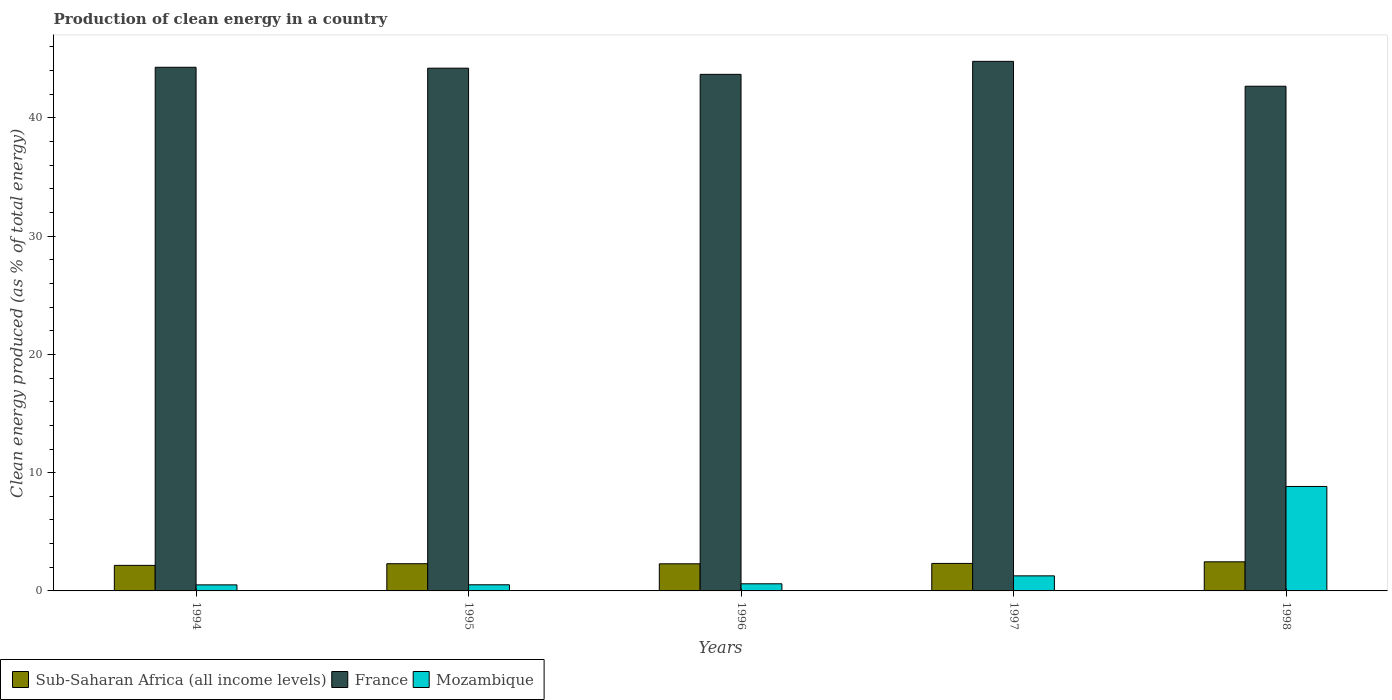Are the number of bars per tick equal to the number of legend labels?
Offer a very short reply. Yes. How many bars are there on the 2nd tick from the right?
Provide a succinct answer. 3. What is the percentage of clean energy produced in Sub-Saharan Africa (all income levels) in 1998?
Offer a very short reply. 2.46. Across all years, what is the maximum percentage of clean energy produced in Mozambique?
Offer a very short reply. 8.83. Across all years, what is the minimum percentage of clean energy produced in Mozambique?
Provide a succinct answer. 0.51. What is the total percentage of clean energy produced in Mozambique in the graph?
Your answer should be compact. 11.74. What is the difference between the percentage of clean energy produced in Sub-Saharan Africa (all income levels) in 1994 and that in 1995?
Provide a succinct answer. -0.14. What is the difference between the percentage of clean energy produced in Mozambique in 1994 and the percentage of clean energy produced in Sub-Saharan Africa (all income levels) in 1995?
Your answer should be compact. -1.79. What is the average percentage of clean energy produced in France per year?
Provide a succinct answer. 43.93. In the year 1998, what is the difference between the percentage of clean energy produced in Mozambique and percentage of clean energy produced in France?
Offer a very short reply. -33.85. In how many years, is the percentage of clean energy produced in Sub-Saharan Africa (all income levels) greater than 16 %?
Offer a terse response. 0. What is the ratio of the percentage of clean energy produced in Mozambique in 1994 to that in 1996?
Your response must be concise. 0.85. Is the percentage of clean energy produced in Sub-Saharan Africa (all income levels) in 1994 less than that in 1998?
Offer a very short reply. Yes. Is the difference between the percentage of clean energy produced in Mozambique in 1995 and 1997 greater than the difference between the percentage of clean energy produced in France in 1995 and 1997?
Give a very brief answer. No. What is the difference between the highest and the second highest percentage of clean energy produced in France?
Your answer should be very brief. 0.5. What is the difference between the highest and the lowest percentage of clean energy produced in France?
Keep it short and to the point. 2.1. What does the 2nd bar from the left in 1996 represents?
Keep it short and to the point. France. What does the 1st bar from the right in 1995 represents?
Provide a short and direct response. Mozambique. Is it the case that in every year, the sum of the percentage of clean energy produced in Sub-Saharan Africa (all income levels) and percentage of clean energy produced in Mozambique is greater than the percentage of clean energy produced in France?
Provide a short and direct response. No. How many bars are there?
Provide a succinct answer. 15. Are the values on the major ticks of Y-axis written in scientific E-notation?
Provide a short and direct response. No. Does the graph contain grids?
Keep it short and to the point. No. Where does the legend appear in the graph?
Keep it short and to the point. Bottom left. What is the title of the graph?
Give a very brief answer. Production of clean energy in a country. What is the label or title of the X-axis?
Make the answer very short. Years. What is the label or title of the Y-axis?
Provide a succinct answer. Clean energy produced (as % of total energy). What is the Clean energy produced (as % of total energy) in Sub-Saharan Africa (all income levels) in 1994?
Provide a short and direct response. 2.16. What is the Clean energy produced (as % of total energy) of France in 1994?
Ensure brevity in your answer.  44.28. What is the Clean energy produced (as % of total energy) of Mozambique in 1994?
Give a very brief answer. 0.51. What is the Clean energy produced (as % of total energy) of Sub-Saharan Africa (all income levels) in 1995?
Give a very brief answer. 2.3. What is the Clean energy produced (as % of total energy) of France in 1995?
Offer a very short reply. 44.21. What is the Clean energy produced (as % of total energy) in Mozambique in 1995?
Provide a short and direct response. 0.52. What is the Clean energy produced (as % of total energy) in Sub-Saharan Africa (all income levels) in 1996?
Your answer should be compact. 2.29. What is the Clean energy produced (as % of total energy) in France in 1996?
Your response must be concise. 43.68. What is the Clean energy produced (as % of total energy) in Mozambique in 1996?
Your response must be concise. 0.6. What is the Clean energy produced (as % of total energy) of Sub-Saharan Africa (all income levels) in 1997?
Give a very brief answer. 2.32. What is the Clean energy produced (as % of total energy) in France in 1997?
Your response must be concise. 44.78. What is the Clean energy produced (as % of total energy) in Mozambique in 1997?
Offer a terse response. 1.27. What is the Clean energy produced (as % of total energy) of Sub-Saharan Africa (all income levels) in 1998?
Your answer should be compact. 2.46. What is the Clean energy produced (as % of total energy) of France in 1998?
Offer a very short reply. 42.68. What is the Clean energy produced (as % of total energy) of Mozambique in 1998?
Provide a succinct answer. 8.83. Across all years, what is the maximum Clean energy produced (as % of total energy) of Sub-Saharan Africa (all income levels)?
Ensure brevity in your answer.  2.46. Across all years, what is the maximum Clean energy produced (as % of total energy) in France?
Make the answer very short. 44.78. Across all years, what is the maximum Clean energy produced (as % of total energy) of Mozambique?
Make the answer very short. 8.83. Across all years, what is the minimum Clean energy produced (as % of total energy) in Sub-Saharan Africa (all income levels)?
Ensure brevity in your answer.  2.16. Across all years, what is the minimum Clean energy produced (as % of total energy) in France?
Ensure brevity in your answer.  42.68. Across all years, what is the minimum Clean energy produced (as % of total energy) in Mozambique?
Provide a succinct answer. 0.51. What is the total Clean energy produced (as % of total energy) in Sub-Saharan Africa (all income levels) in the graph?
Offer a very short reply. 11.54. What is the total Clean energy produced (as % of total energy) of France in the graph?
Your response must be concise. 219.63. What is the total Clean energy produced (as % of total energy) of Mozambique in the graph?
Keep it short and to the point. 11.74. What is the difference between the Clean energy produced (as % of total energy) of Sub-Saharan Africa (all income levels) in 1994 and that in 1995?
Offer a terse response. -0.14. What is the difference between the Clean energy produced (as % of total energy) of France in 1994 and that in 1995?
Give a very brief answer. 0.08. What is the difference between the Clean energy produced (as % of total energy) of Mozambique in 1994 and that in 1995?
Provide a short and direct response. -0.01. What is the difference between the Clean energy produced (as % of total energy) in Sub-Saharan Africa (all income levels) in 1994 and that in 1996?
Provide a succinct answer. -0.13. What is the difference between the Clean energy produced (as % of total energy) in France in 1994 and that in 1996?
Ensure brevity in your answer.  0.6. What is the difference between the Clean energy produced (as % of total energy) in Mozambique in 1994 and that in 1996?
Offer a terse response. -0.09. What is the difference between the Clean energy produced (as % of total energy) of Sub-Saharan Africa (all income levels) in 1994 and that in 1997?
Ensure brevity in your answer.  -0.16. What is the difference between the Clean energy produced (as % of total energy) of France in 1994 and that in 1997?
Ensure brevity in your answer.  -0.5. What is the difference between the Clean energy produced (as % of total energy) in Mozambique in 1994 and that in 1997?
Give a very brief answer. -0.76. What is the difference between the Clean energy produced (as % of total energy) of Sub-Saharan Africa (all income levels) in 1994 and that in 1998?
Ensure brevity in your answer.  -0.3. What is the difference between the Clean energy produced (as % of total energy) in France in 1994 and that in 1998?
Your answer should be compact. 1.6. What is the difference between the Clean energy produced (as % of total energy) in Mozambique in 1994 and that in 1998?
Your response must be concise. -8.32. What is the difference between the Clean energy produced (as % of total energy) in Sub-Saharan Africa (all income levels) in 1995 and that in 1996?
Offer a terse response. 0.01. What is the difference between the Clean energy produced (as % of total energy) of France in 1995 and that in 1996?
Make the answer very short. 0.52. What is the difference between the Clean energy produced (as % of total energy) in Mozambique in 1995 and that in 1996?
Make the answer very short. -0.08. What is the difference between the Clean energy produced (as % of total energy) in Sub-Saharan Africa (all income levels) in 1995 and that in 1997?
Give a very brief answer. -0.02. What is the difference between the Clean energy produced (as % of total energy) of France in 1995 and that in 1997?
Give a very brief answer. -0.58. What is the difference between the Clean energy produced (as % of total energy) of Mozambique in 1995 and that in 1997?
Offer a very short reply. -0.76. What is the difference between the Clean energy produced (as % of total energy) in Sub-Saharan Africa (all income levels) in 1995 and that in 1998?
Your answer should be compact. -0.16. What is the difference between the Clean energy produced (as % of total energy) in France in 1995 and that in 1998?
Give a very brief answer. 1.53. What is the difference between the Clean energy produced (as % of total energy) of Mozambique in 1995 and that in 1998?
Make the answer very short. -8.31. What is the difference between the Clean energy produced (as % of total energy) in Sub-Saharan Africa (all income levels) in 1996 and that in 1997?
Provide a short and direct response. -0.03. What is the difference between the Clean energy produced (as % of total energy) in France in 1996 and that in 1997?
Keep it short and to the point. -1.1. What is the difference between the Clean energy produced (as % of total energy) of Mozambique in 1996 and that in 1997?
Give a very brief answer. -0.67. What is the difference between the Clean energy produced (as % of total energy) of Sub-Saharan Africa (all income levels) in 1996 and that in 1998?
Your response must be concise. -0.17. What is the difference between the Clean energy produced (as % of total energy) of France in 1996 and that in 1998?
Provide a short and direct response. 1. What is the difference between the Clean energy produced (as % of total energy) in Mozambique in 1996 and that in 1998?
Provide a succinct answer. -8.23. What is the difference between the Clean energy produced (as % of total energy) of Sub-Saharan Africa (all income levels) in 1997 and that in 1998?
Offer a terse response. -0.14. What is the difference between the Clean energy produced (as % of total energy) in France in 1997 and that in 1998?
Your answer should be very brief. 2.1. What is the difference between the Clean energy produced (as % of total energy) in Mozambique in 1997 and that in 1998?
Provide a succinct answer. -7.56. What is the difference between the Clean energy produced (as % of total energy) of Sub-Saharan Africa (all income levels) in 1994 and the Clean energy produced (as % of total energy) of France in 1995?
Offer a terse response. -42.05. What is the difference between the Clean energy produced (as % of total energy) of Sub-Saharan Africa (all income levels) in 1994 and the Clean energy produced (as % of total energy) of Mozambique in 1995?
Your answer should be compact. 1.64. What is the difference between the Clean energy produced (as % of total energy) of France in 1994 and the Clean energy produced (as % of total energy) of Mozambique in 1995?
Offer a terse response. 43.76. What is the difference between the Clean energy produced (as % of total energy) in Sub-Saharan Africa (all income levels) in 1994 and the Clean energy produced (as % of total energy) in France in 1996?
Your answer should be very brief. -41.52. What is the difference between the Clean energy produced (as % of total energy) in Sub-Saharan Africa (all income levels) in 1994 and the Clean energy produced (as % of total energy) in Mozambique in 1996?
Your response must be concise. 1.56. What is the difference between the Clean energy produced (as % of total energy) in France in 1994 and the Clean energy produced (as % of total energy) in Mozambique in 1996?
Your answer should be compact. 43.68. What is the difference between the Clean energy produced (as % of total energy) in Sub-Saharan Africa (all income levels) in 1994 and the Clean energy produced (as % of total energy) in France in 1997?
Make the answer very short. -42.62. What is the difference between the Clean energy produced (as % of total energy) in Sub-Saharan Africa (all income levels) in 1994 and the Clean energy produced (as % of total energy) in Mozambique in 1997?
Your answer should be very brief. 0.89. What is the difference between the Clean energy produced (as % of total energy) in France in 1994 and the Clean energy produced (as % of total energy) in Mozambique in 1997?
Keep it short and to the point. 43.01. What is the difference between the Clean energy produced (as % of total energy) of Sub-Saharan Africa (all income levels) in 1994 and the Clean energy produced (as % of total energy) of France in 1998?
Offer a very short reply. -40.52. What is the difference between the Clean energy produced (as % of total energy) in Sub-Saharan Africa (all income levels) in 1994 and the Clean energy produced (as % of total energy) in Mozambique in 1998?
Provide a short and direct response. -6.67. What is the difference between the Clean energy produced (as % of total energy) in France in 1994 and the Clean energy produced (as % of total energy) in Mozambique in 1998?
Give a very brief answer. 35.45. What is the difference between the Clean energy produced (as % of total energy) in Sub-Saharan Africa (all income levels) in 1995 and the Clean energy produced (as % of total energy) in France in 1996?
Give a very brief answer. -41.38. What is the difference between the Clean energy produced (as % of total energy) in Sub-Saharan Africa (all income levels) in 1995 and the Clean energy produced (as % of total energy) in Mozambique in 1996?
Your answer should be compact. 1.7. What is the difference between the Clean energy produced (as % of total energy) of France in 1995 and the Clean energy produced (as % of total energy) of Mozambique in 1996?
Offer a terse response. 43.6. What is the difference between the Clean energy produced (as % of total energy) of Sub-Saharan Africa (all income levels) in 1995 and the Clean energy produced (as % of total energy) of France in 1997?
Provide a short and direct response. -42.48. What is the difference between the Clean energy produced (as % of total energy) in Sub-Saharan Africa (all income levels) in 1995 and the Clean energy produced (as % of total energy) in Mozambique in 1997?
Your answer should be very brief. 1.03. What is the difference between the Clean energy produced (as % of total energy) of France in 1995 and the Clean energy produced (as % of total energy) of Mozambique in 1997?
Your answer should be very brief. 42.93. What is the difference between the Clean energy produced (as % of total energy) in Sub-Saharan Africa (all income levels) in 1995 and the Clean energy produced (as % of total energy) in France in 1998?
Ensure brevity in your answer.  -40.38. What is the difference between the Clean energy produced (as % of total energy) in Sub-Saharan Africa (all income levels) in 1995 and the Clean energy produced (as % of total energy) in Mozambique in 1998?
Your answer should be compact. -6.53. What is the difference between the Clean energy produced (as % of total energy) of France in 1995 and the Clean energy produced (as % of total energy) of Mozambique in 1998?
Offer a very short reply. 35.37. What is the difference between the Clean energy produced (as % of total energy) in Sub-Saharan Africa (all income levels) in 1996 and the Clean energy produced (as % of total energy) in France in 1997?
Your answer should be very brief. -42.49. What is the difference between the Clean energy produced (as % of total energy) of Sub-Saharan Africa (all income levels) in 1996 and the Clean energy produced (as % of total energy) of Mozambique in 1997?
Provide a succinct answer. 1.02. What is the difference between the Clean energy produced (as % of total energy) of France in 1996 and the Clean energy produced (as % of total energy) of Mozambique in 1997?
Give a very brief answer. 42.41. What is the difference between the Clean energy produced (as % of total energy) of Sub-Saharan Africa (all income levels) in 1996 and the Clean energy produced (as % of total energy) of France in 1998?
Your answer should be very brief. -40.39. What is the difference between the Clean energy produced (as % of total energy) in Sub-Saharan Africa (all income levels) in 1996 and the Clean energy produced (as % of total energy) in Mozambique in 1998?
Make the answer very short. -6.54. What is the difference between the Clean energy produced (as % of total energy) of France in 1996 and the Clean energy produced (as % of total energy) of Mozambique in 1998?
Offer a terse response. 34.85. What is the difference between the Clean energy produced (as % of total energy) of Sub-Saharan Africa (all income levels) in 1997 and the Clean energy produced (as % of total energy) of France in 1998?
Your response must be concise. -40.35. What is the difference between the Clean energy produced (as % of total energy) of Sub-Saharan Africa (all income levels) in 1997 and the Clean energy produced (as % of total energy) of Mozambique in 1998?
Provide a succinct answer. -6.51. What is the difference between the Clean energy produced (as % of total energy) of France in 1997 and the Clean energy produced (as % of total energy) of Mozambique in 1998?
Offer a terse response. 35.95. What is the average Clean energy produced (as % of total energy) of Sub-Saharan Africa (all income levels) per year?
Keep it short and to the point. 2.31. What is the average Clean energy produced (as % of total energy) in France per year?
Give a very brief answer. 43.93. What is the average Clean energy produced (as % of total energy) in Mozambique per year?
Make the answer very short. 2.35. In the year 1994, what is the difference between the Clean energy produced (as % of total energy) in Sub-Saharan Africa (all income levels) and Clean energy produced (as % of total energy) in France?
Keep it short and to the point. -42.12. In the year 1994, what is the difference between the Clean energy produced (as % of total energy) of Sub-Saharan Africa (all income levels) and Clean energy produced (as % of total energy) of Mozambique?
Your answer should be compact. 1.65. In the year 1994, what is the difference between the Clean energy produced (as % of total energy) of France and Clean energy produced (as % of total energy) of Mozambique?
Offer a terse response. 43.77. In the year 1995, what is the difference between the Clean energy produced (as % of total energy) in Sub-Saharan Africa (all income levels) and Clean energy produced (as % of total energy) in France?
Keep it short and to the point. -41.91. In the year 1995, what is the difference between the Clean energy produced (as % of total energy) of Sub-Saharan Africa (all income levels) and Clean energy produced (as % of total energy) of Mozambique?
Offer a very short reply. 1.78. In the year 1995, what is the difference between the Clean energy produced (as % of total energy) in France and Clean energy produced (as % of total energy) in Mozambique?
Provide a succinct answer. 43.69. In the year 1996, what is the difference between the Clean energy produced (as % of total energy) of Sub-Saharan Africa (all income levels) and Clean energy produced (as % of total energy) of France?
Your answer should be compact. -41.39. In the year 1996, what is the difference between the Clean energy produced (as % of total energy) of Sub-Saharan Africa (all income levels) and Clean energy produced (as % of total energy) of Mozambique?
Offer a very short reply. 1.69. In the year 1996, what is the difference between the Clean energy produced (as % of total energy) in France and Clean energy produced (as % of total energy) in Mozambique?
Provide a succinct answer. 43.08. In the year 1997, what is the difference between the Clean energy produced (as % of total energy) in Sub-Saharan Africa (all income levels) and Clean energy produced (as % of total energy) in France?
Your response must be concise. -42.46. In the year 1997, what is the difference between the Clean energy produced (as % of total energy) in Sub-Saharan Africa (all income levels) and Clean energy produced (as % of total energy) in Mozambique?
Ensure brevity in your answer.  1.05. In the year 1997, what is the difference between the Clean energy produced (as % of total energy) of France and Clean energy produced (as % of total energy) of Mozambique?
Provide a short and direct response. 43.51. In the year 1998, what is the difference between the Clean energy produced (as % of total energy) in Sub-Saharan Africa (all income levels) and Clean energy produced (as % of total energy) in France?
Offer a terse response. -40.22. In the year 1998, what is the difference between the Clean energy produced (as % of total energy) in Sub-Saharan Africa (all income levels) and Clean energy produced (as % of total energy) in Mozambique?
Your response must be concise. -6.37. In the year 1998, what is the difference between the Clean energy produced (as % of total energy) in France and Clean energy produced (as % of total energy) in Mozambique?
Ensure brevity in your answer.  33.85. What is the ratio of the Clean energy produced (as % of total energy) of Sub-Saharan Africa (all income levels) in 1994 to that in 1995?
Make the answer very short. 0.94. What is the ratio of the Clean energy produced (as % of total energy) in Mozambique in 1994 to that in 1995?
Make the answer very short. 0.99. What is the ratio of the Clean energy produced (as % of total energy) of Sub-Saharan Africa (all income levels) in 1994 to that in 1996?
Provide a short and direct response. 0.94. What is the ratio of the Clean energy produced (as % of total energy) in France in 1994 to that in 1996?
Your answer should be very brief. 1.01. What is the ratio of the Clean energy produced (as % of total energy) in Mozambique in 1994 to that in 1996?
Your answer should be very brief. 0.85. What is the ratio of the Clean energy produced (as % of total energy) of Sub-Saharan Africa (all income levels) in 1994 to that in 1997?
Offer a very short reply. 0.93. What is the ratio of the Clean energy produced (as % of total energy) in France in 1994 to that in 1997?
Give a very brief answer. 0.99. What is the ratio of the Clean energy produced (as % of total energy) of Mozambique in 1994 to that in 1997?
Give a very brief answer. 0.4. What is the ratio of the Clean energy produced (as % of total energy) in Sub-Saharan Africa (all income levels) in 1994 to that in 1998?
Keep it short and to the point. 0.88. What is the ratio of the Clean energy produced (as % of total energy) in France in 1994 to that in 1998?
Your answer should be very brief. 1.04. What is the ratio of the Clean energy produced (as % of total energy) of Mozambique in 1994 to that in 1998?
Make the answer very short. 0.06. What is the ratio of the Clean energy produced (as % of total energy) of France in 1995 to that in 1996?
Ensure brevity in your answer.  1.01. What is the ratio of the Clean energy produced (as % of total energy) of Mozambique in 1995 to that in 1996?
Provide a short and direct response. 0.86. What is the ratio of the Clean energy produced (as % of total energy) of France in 1995 to that in 1997?
Provide a short and direct response. 0.99. What is the ratio of the Clean energy produced (as % of total energy) of Mozambique in 1995 to that in 1997?
Your answer should be compact. 0.41. What is the ratio of the Clean energy produced (as % of total energy) in Sub-Saharan Africa (all income levels) in 1995 to that in 1998?
Your answer should be compact. 0.94. What is the ratio of the Clean energy produced (as % of total energy) of France in 1995 to that in 1998?
Make the answer very short. 1.04. What is the ratio of the Clean energy produced (as % of total energy) in Mozambique in 1995 to that in 1998?
Provide a succinct answer. 0.06. What is the ratio of the Clean energy produced (as % of total energy) in Sub-Saharan Africa (all income levels) in 1996 to that in 1997?
Your answer should be very brief. 0.99. What is the ratio of the Clean energy produced (as % of total energy) of France in 1996 to that in 1997?
Keep it short and to the point. 0.98. What is the ratio of the Clean energy produced (as % of total energy) in Mozambique in 1996 to that in 1997?
Offer a very short reply. 0.47. What is the ratio of the Clean energy produced (as % of total energy) of Sub-Saharan Africa (all income levels) in 1996 to that in 1998?
Provide a succinct answer. 0.93. What is the ratio of the Clean energy produced (as % of total energy) of France in 1996 to that in 1998?
Give a very brief answer. 1.02. What is the ratio of the Clean energy produced (as % of total energy) of Mozambique in 1996 to that in 1998?
Provide a short and direct response. 0.07. What is the ratio of the Clean energy produced (as % of total energy) in Sub-Saharan Africa (all income levels) in 1997 to that in 1998?
Offer a terse response. 0.94. What is the ratio of the Clean energy produced (as % of total energy) in France in 1997 to that in 1998?
Provide a short and direct response. 1.05. What is the ratio of the Clean energy produced (as % of total energy) of Mozambique in 1997 to that in 1998?
Provide a succinct answer. 0.14. What is the difference between the highest and the second highest Clean energy produced (as % of total energy) of Sub-Saharan Africa (all income levels)?
Ensure brevity in your answer.  0.14. What is the difference between the highest and the second highest Clean energy produced (as % of total energy) of France?
Give a very brief answer. 0.5. What is the difference between the highest and the second highest Clean energy produced (as % of total energy) of Mozambique?
Ensure brevity in your answer.  7.56. What is the difference between the highest and the lowest Clean energy produced (as % of total energy) in Sub-Saharan Africa (all income levels)?
Provide a short and direct response. 0.3. What is the difference between the highest and the lowest Clean energy produced (as % of total energy) of France?
Keep it short and to the point. 2.1. What is the difference between the highest and the lowest Clean energy produced (as % of total energy) in Mozambique?
Make the answer very short. 8.32. 